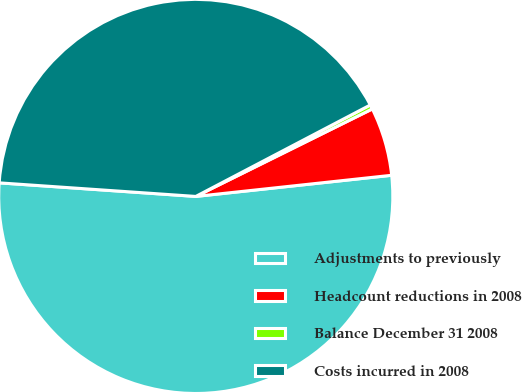<chart> <loc_0><loc_0><loc_500><loc_500><pie_chart><fcel>Adjustments to previously<fcel>Headcount reductions in 2008<fcel>Balance December 31 2008<fcel>Costs incurred in 2008<nl><fcel>52.81%<fcel>5.61%<fcel>0.36%<fcel>41.22%<nl></chart> 